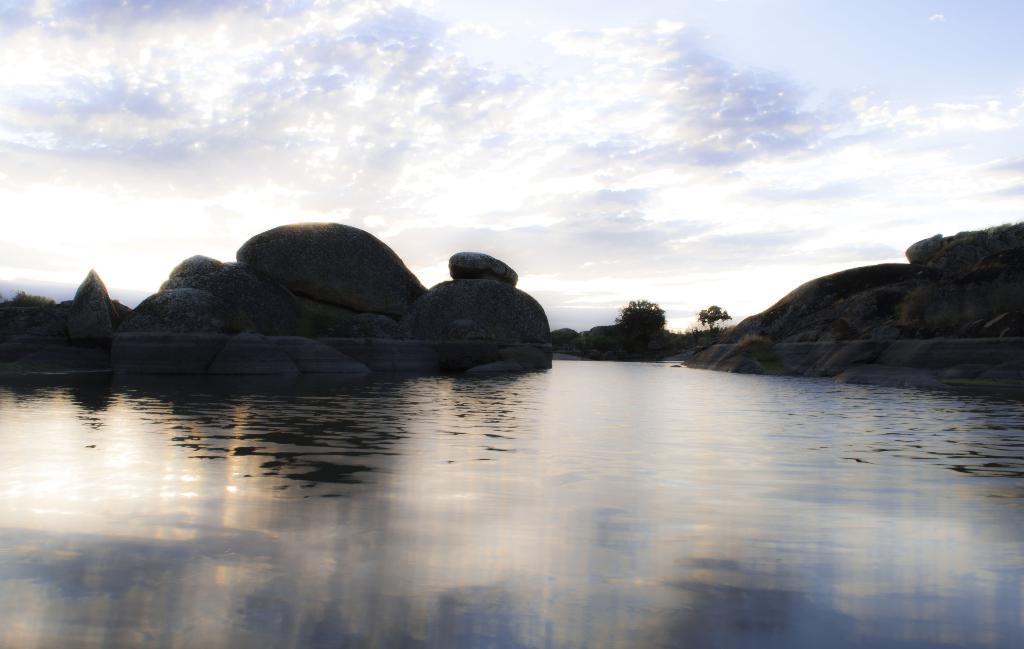Can you describe this image briefly? In the picture I can see water, rocks, trees and the cloudy sky in the background. 